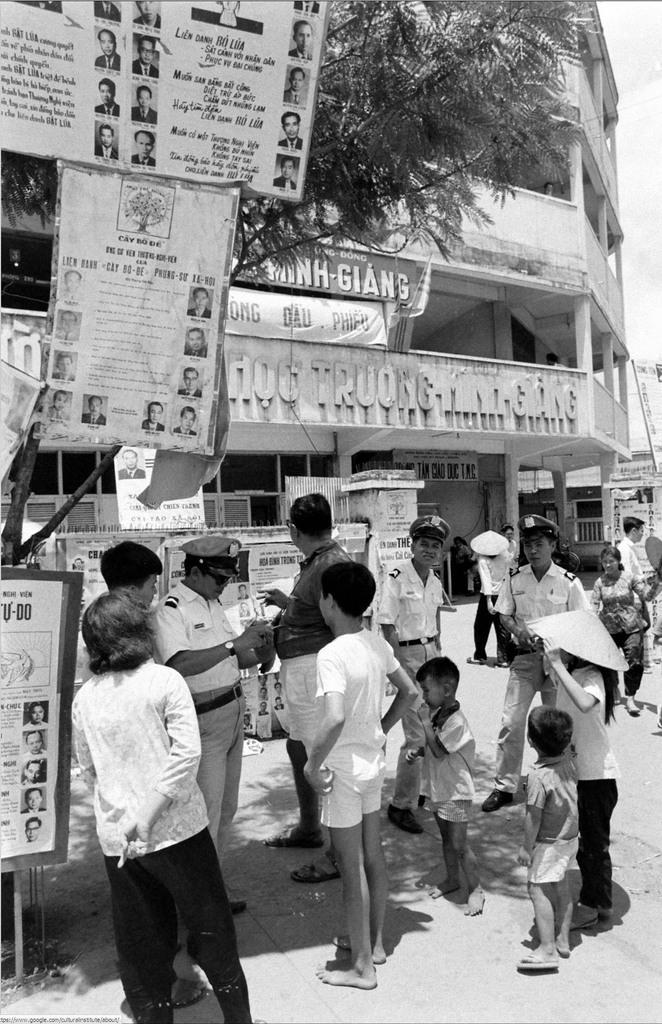What is the main structure in the center of the image? There is a building in the center of the image. What is attached to the building? There is a banner on the building. What type of vegetation is on the left side of the image? There is a tree on the left side of the image. What objects can be seen in the image besides the building and tree? There are boards in the image. Who or what is present at the bottom of the image? People are standing at the bottom of the image. How many trays of food are being carried by the bears in the image? There are no bears or trays of food present in the image. What is the value of the item being advertised on the banner? The value of the item being advertised on the banner cannot be determined from the image alone. 